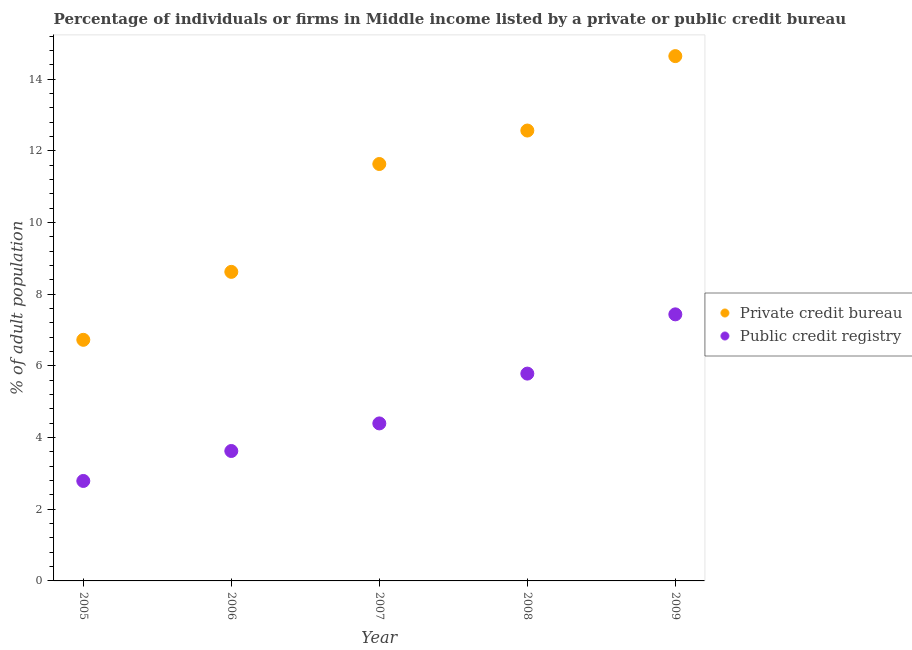How many different coloured dotlines are there?
Your answer should be very brief. 2. Is the number of dotlines equal to the number of legend labels?
Make the answer very short. Yes. What is the percentage of firms listed by private credit bureau in 2005?
Keep it short and to the point. 6.73. Across all years, what is the maximum percentage of firms listed by public credit bureau?
Provide a succinct answer. 7.44. Across all years, what is the minimum percentage of firms listed by private credit bureau?
Offer a very short reply. 6.73. What is the total percentage of firms listed by public credit bureau in the graph?
Your response must be concise. 24.04. What is the difference between the percentage of firms listed by public credit bureau in 2005 and that in 2008?
Ensure brevity in your answer.  -3. What is the difference between the percentage of firms listed by private credit bureau in 2007 and the percentage of firms listed by public credit bureau in 2006?
Provide a succinct answer. 8.01. What is the average percentage of firms listed by private credit bureau per year?
Keep it short and to the point. 10.84. In the year 2008, what is the difference between the percentage of firms listed by public credit bureau and percentage of firms listed by private credit bureau?
Your answer should be very brief. -6.78. In how many years, is the percentage of firms listed by public credit bureau greater than 5.6 %?
Your answer should be very brief. 2. What is the ratio of the percentage of firms listed by public credit bureau in 2005 to that in 2007?
Make the answer very short. 0.63. Is the difference between the percentage of firms listed by private credit bureau in 2005 and 2006 greater than the difference between the percentage of firms listed by public credit bureau in 2005 and 2006?
Your response must be concise. No. What is the difference between the highest and the second highest percentage of firms listed by public credit bureau?
Provide a succinct answer. 1.65. What is the difference between the highest and the lowest percentage of firms listed by public credit bureau?
Your answer should be compact. 4.65. In how many years, is the percentage of firms listed by public credit bureau greater than the average percentage of firms listed by public credit bureau taken over all years?
Keep it short and to the point. 2. Does the percentage of firms listed by private credit bureau monotonically increase over the years?
Provide a succinct answer. Yes. How many years are there in the graph?
Make the answer very short. 5. What is the difference between two consecutive major ticks on the Y-axis?
Give a very brief answer. 2. Are the values on the major ticks of Y-axis written in scientific E-notation?
Make the answer very short. No. Does the graph contain any zero values?
Ensure brevity in your answer.  No. How many legend labels are there?
Your response must be concise. 2. What is the title of the graph?
Make the answer very short. Percentage of individuals or firms in Middle income listed by a private or public credit bureau. Does "Services" appear as one of the legend labels in the graph?
Your answer should be very brief. No. What is the label or title of the Y-axis?
Offer a terse response. % of adult population. What is the % of adult population in Private credit bureau in 2005?
Offer a very short reply. 6.73. What is the % of adult population in Public credit registry in 2005?
Your response must be concise. 2.79. What is the % of adult population in Private credit bureau in 2006?
Offer a very short reply. 8.62. What is the % of adult population in Public credit registry in 2006?
Keep it short and to the point. 3.63. What is the % of adult population of Private credit bureau in 2007?
Keep it short and to the point. 11.63. What is the % of adult population of Public credit registry in 2007?
Provide a short and direct response. 4.4. What is the % of adult population in Private credit bureau in 2008?
Provide a short and direct response. 12.57. What is the % of adult population in Public credit registry in 2008?
Give a very brief answer. 5.79. What is the % of adult population in Private credit bureau in 2009?
Your answer should be compact. 14.65. What is the % of adult population of Public credit registry in 2009?
Make the answer very short. 7.44. Across all years, what is the maximum % of adult population of Private credit bureau?
Provide a short and direct response. 14.65. Across all years, what is the maximum % of adult population in Public credit registry?
Offer a terse response. 7.44. Across all years, what is the minimum % of adult population in Private credit bureau?
Make the answer very short. 6.73. Across all years, what is the minimum % of adult population in Public credit registry?
Give a very brief answer. 2.79. What is the total % of adult population of Private credit bureau in the graph?
Ensure brevity in your answer.  54.2. What is the total % of adult population of Public credit registry in the graph?
Offer a terse response. 24.04. What is the difference between the % of adult population in Private credit bureau in 2005 and that in 2006?
Give a very brief answer. -1.9. What is the difference between the % of adult population of Public credit registry in 2005 and that in 2006?
Your response must be concise. -0.84. What is the difference between the % of adult population of Private credit bureau in 2005 and that in 2007?
Keep it short and to the point. -4.91. What is the difference between the % of adult population of Public credit registry in 2005 and that in 2007?
Your response must be concise. -1.61. What is the difference between the % of adult population of Private credit bureau in 2005 and that in 2008?
Offer a terse response. -5.84. What is the difference between the % of adult population of Public credit registry in 2005 and that in 2008?
Provide a succinct answer. -3. What is the difference between the % of adult population in Private credit bureau in 2005 and that in 2009?
Offer a very short reply. -7.92. What is the difference between the % of adult population of Public credit registry in 2005 and that in 2009?
Your answer should be compact. -4.65. What is the difference between the % of adult population in Private credit bureau in 2006 and that in 2007?
Offer a terse response. -3.01. What is the difference between the % of adult population of Public credit registry in 2006 and that in 2007?
Give a very brief answer. -0.77. What is the difference between the % of adult population of Private credit bureau in 2006 and that in 2008?
Ensure brevity in your answer.  -3.94. What is the difference between the % of adult population in Public credit registry in 2006 and that in 2008?
Your answer should be compact. -2.16. What is the difference between the % of adult population in Private credit bureau in 2006 and that in 2009?
Provide a succinct answer. -6.02. What is the difference between the % of adult population of Public credit registry in 2006 and that in 2009?
Offer a terse response. -3.81. What is the difference between the % of adult population in Private credit bureau in 2007 and that in 2008?
Give a very brief answer. -0.93. What is the difference between the % of adult population in Public credit registry in 2007 and that in 2008?
Your answer should be very brief. -1.39. What is the difference between the % of adult population of Private credit bureau in 2007 and that in 2009?
Offer a terse response. -3.01. What is the difference between the % of adult population of Public credit registry in 2007 and that in 2009?
Your answer should be compact. -3.04. What is the difference between the % of adult population of Private credit bureau in 2008 and that in 2009?
Offer a very short reply. -2.08. What is the difference between the % of adult population in Public credit registry in 2008 and that in 2009?
Offer a very short reply. -1.65. What is the difference between the % of adult population of Private credit bureau in 2005 and the % of adult population of Public credit registry in 2006?
Give a very brief answer. 3.1. What is the difference between the % of adult population in Private credit bureau in 2005 and the % of adult population in Public credit registry in 2007?
Offer a terse response. 2.33. What is the difference between the % of adult population in Private credit bureau in 2005 and the % of adult population in Public credit registry in 2008?
Your answer should be compact. 0.94. What is the difference between the % of adult population of Private credit bureau in 2005 and the % of adult population of Public credit registry in 2009?
Your answer should be very brief. -0.71. What is the difference between the % of adult population in Private credit bureau in 2006 and the % of adult population in Public credit registry in 2007?
Ensure brevity in your answer.  4.23. What is the difference between the % of adult population of Private credit bureau in 2006 and the % of adult population of Public credit registry in 2008?
Your answer should be compact. 2.84. What is the difference between the % of adult population of Private credit bureau in 2006 and the % of adult population of Public credit registry in 2009?
Your answer should be compact. 1.19. What is the difference between the % of adult population of Private credit bureau in 2007 and the % of adult population of Public credit registry in 2008?
Give a very brief answer. 5.85. What is the difference between the % of adult population in Private credit bureau in 2007 and the % of adult population in Public credit registry in 2009?
Give a very brief answer. 4.2. What is the difference between the % of adult population of Private credit bureau in 2008 and the % of adult population of Public credit registry in 2009?
Make the answer very short. 5.13. What is the average % of adult population of Private credit bureau per year?
Provide a succinct answer. 10.84. What is the average % of adult population of Public credit registry per year?
Your answer should be compact. 4.81. In the year 2005, what is the difference between the % of adult population of Private credit bureau and % of adult population of Public credit registry?
Your response must be concise. 3.94. In the year 2006, what is the difference between the % of adult population in Private credit bureau and % of adult population in Public credit registry?
Give a very brief answer. 5. In the year 2007, what is the difference between the % of adult population in Private credit bureau and % of adult population in Public credit registry?
Provide a succinct answer. 7.24. In the year 2008, what is the difference between the % of adult population in Private credit bureau and % of adult population in Public credit registry?
Offer a very short reply. 6.78. In the year 2009, what is the difference between the % of adult population in Private credit bureau and % of adult population in Public credit registry?
Your response must be concise. 7.21. What is the ratio of the % of adult population of Private credit bureau in 2005 to that in 2006?
Offer a terse response. 0.78. What is the ratio of the % of adult population of Public credit registry in 2005 to that in 2006?
Ensure brevity in your answer.  0.77. What is the ratio of the % of adult population in Private credit bureau in 2005 to that in 2007?
Offer a terse response. 0.58. What is the ratio of the % of adult population in Public credit registry in 2005 to that in 2007?
Give a very brief answer. 0.63. What is the ratio of the % of adult population in Private credit bureau in 2005 to that in 2008?
Your response must be concise. 0.54. What is the ratio of the % of adult population in Public credit registry in 2005 to that in 2008?
Offer a terse response. 0.48. What is the ratio of the % of adult population in Private credit bureau in 2005 to that in 2009?
Your answer should be very brief. 0.46. What is the ratio of the % of adult population of Private credit bureau in 2006 to that in 2007?
Offer a terse response. 0.74. What is the ratio of the % of adult population of Public credit registry in 2006 to that in 2007?
Give a very brief answer. 0.82. What is the ratio of the % of adult population in Private credit bureau in 2006 to that in 2008?
Offer a very short reply. 0.69. What is the ratio of the % of adult population in Public credit registry in 2006 to that in 2008?
Provide a short and direct response. 0.63. What is the ratio of the % of adult population of Private credit bureau in 2006 to that in 2009?
Your response must be concise. 0.59. What is the ratio of the % of adult population of Public credit registry in 2006 to that in 2009?
Keep it short and to the point. 0.49. What is the ratio of the % of adult population of Private credit bureau in 2007 to that in 2008?
Provide a short and direct response. 0.93. What is the ratio of the % of adult population of Public credit registry in 2007 to that in 2008?
Ensure brevity in your answer.  0.76. What is the ratio of the % of adult population of Private credit bureau in 2007 to that in 2009?
Your answer should be very brief. 0.79. What is the ratio of the % of adult population in Public credit registry in 2007 to that in 2009?
Give a very brief answer. 0.59. What is the ratio of the % of adult population of Private credit bureau in 2008 to that in 2009?
Ensure brevity in your answer.  0.86. What is the ratio of the % of adult population of Public credit registry in 2008 to that in 2009?
Your answer should be compact. 0.78. What is the difference between the highest and the second highest % of adult population of Private credit bureau?
Provide a succinct answer. 2.08. What is the difference between the highest and the second highest % of adult population in Public credit registry?
Your answer should be compact. 1.65. What is the difference between the highest and the lowest % of adult population of Private credit bureau?
Your answer should be compact. 7.92. What is the difference between the highest and the lowest % of adult population in Public credit registry?
Your answer should be compact. 4.65. 